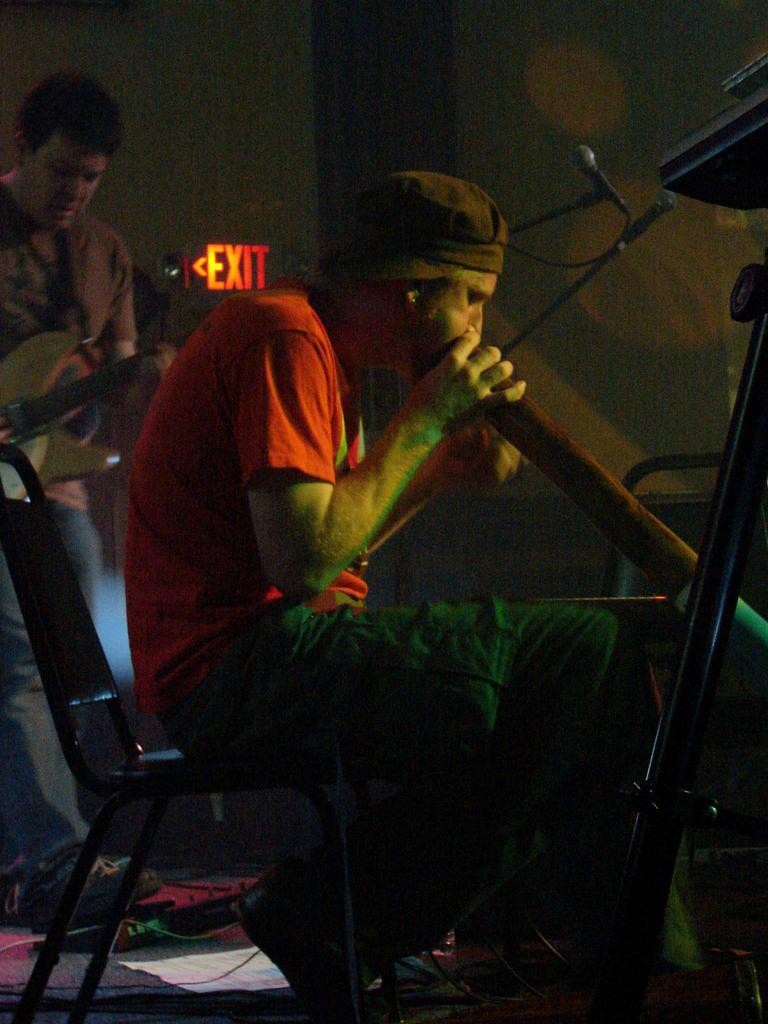Describe this image in one or two sentences. This picture shows a man seated on a chair and playing an instrument and we see a man playing guitar on his back. 